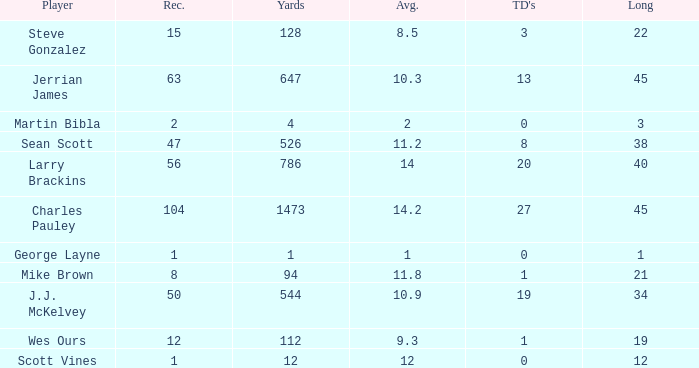What is the average for wes ours with over 1 reception and under 1 TD? None. 